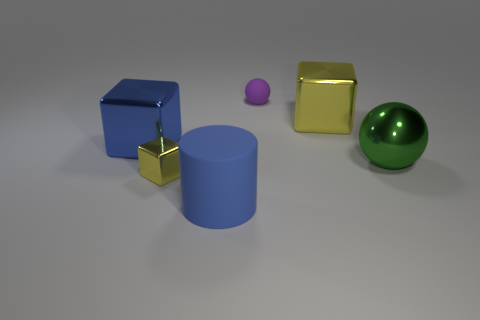Add 3 blue rubber things. How many objects exist? 9 Subtract all cylinders. How many objects are left? 5 Add 3 small purple rubber spheres. How many small purple rubber spheres exist? 4 Subtract 1 blue cylinders. How many objects are left? 5 Subtract all small blue balls. Subtract all tiny objects. How many objects are left? 4 Add 4 small shiny objects. How many small shiny objects are left? 5 